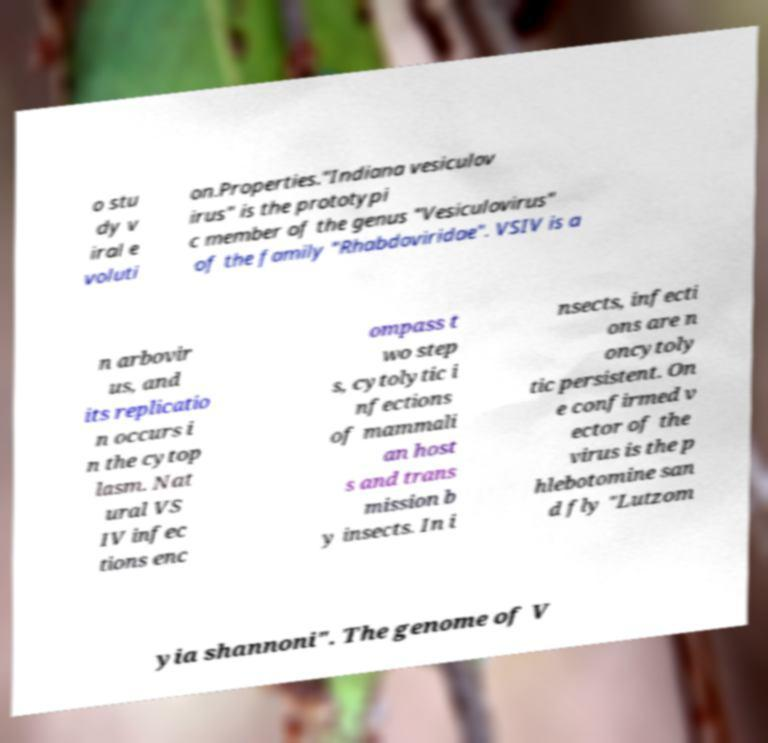Can you read and provide the text displayed in the image?This photo seems to have some interesting text. Can you extract and type it out for me? o stu dy v iral e voluti on.Properties."Indiana vesiculov irus" is the prototypi c member of the genus "Vesiculovirus" of the family "Rhabdoviridae". VSIV is a n arbovir us, and its replicatio n occurs i n the cytop lasm. Nat ural VS IV infec tions enc ompass t wo step s, cytolytic i nfections of mammali an host s and trans mission b y insects. In i nsects, infecti ons are n oncytoly tic persistent. On e confirmed v ector of the virus is the p hlebotomine san d fly "Lutzom yia shannoni". The genome of V 